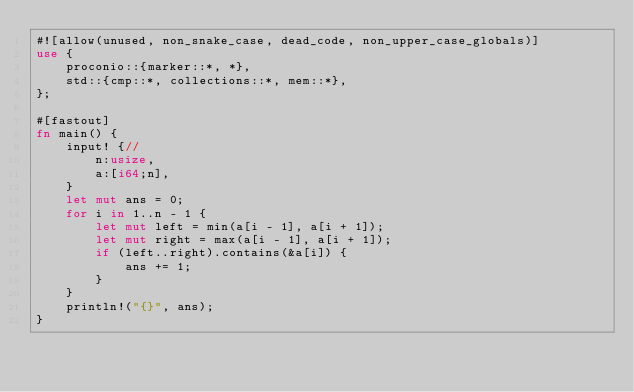Convert code to text. <code><loc_0><loc_0><loc_500><loc_500><_Rust_>#![allow(unused, non_snake_case, dead_code, non_upper_case_globals)]
use {
    proconio::{marker::*, *},
    std::{cmp::*, collections::*, mem::*},
};

#[fastout]
fn main() {
    input! {//
        n:usize,
        a:[i64;n],
    }
    let mut ans = 0;
    for i in 1..n - 1 {
        let mut left = min(a[i - 1], a[i + 1]);
        let mut right = max(a[i - 1], a[i + 1]);
        if (left..right).contains(&a[i]) {
            ans += 1;
        }
    }
    println!("{}", ans);
}
</code> 